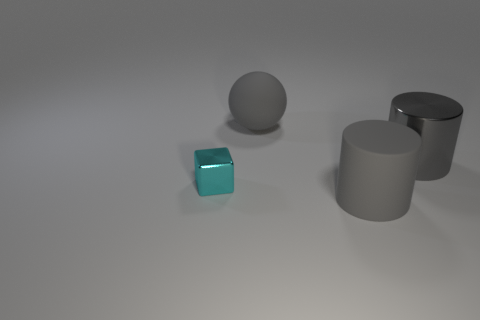Are there any other things that have the same shape as the small cyan thing?
Provide a short and direct response. No. There is a thing that is to the right of the cylinder that is to the left of the gray object that is right of the gray matte cylinder; what is its size?
Offer a terse response. Large. Is the number of gray matte things behind the metal cube greater than the number of rubber objects right of the big gray rubber sphere?
Offer a terse response. No. How many large gray rubber things are in front of the gray cylinder that is to the right of the large gray matte cylinder?
Ensure brevity in your answer.  1. Is there a large object that has the same color as the shiny cylinder?
Offer a very short reply. Yes. Do the shiny cube and the gray rubber sphere have the same size?
Give a very brief answer. No. Does the big matte cylinder have the same color as the tiny block?
Offer a terse response. No. What is the material of the large gray thing to the left of the big cylinder in front of the cyan shiny object?
Provide a short and direct response. Rubber. There is a metallic object that is on the right side of the shiny block; is its size the same as the ball?
Make the answer very short. Yes. What number of matte things are large purple objects or big gray cylinders?
Offer a terse response. 1. 